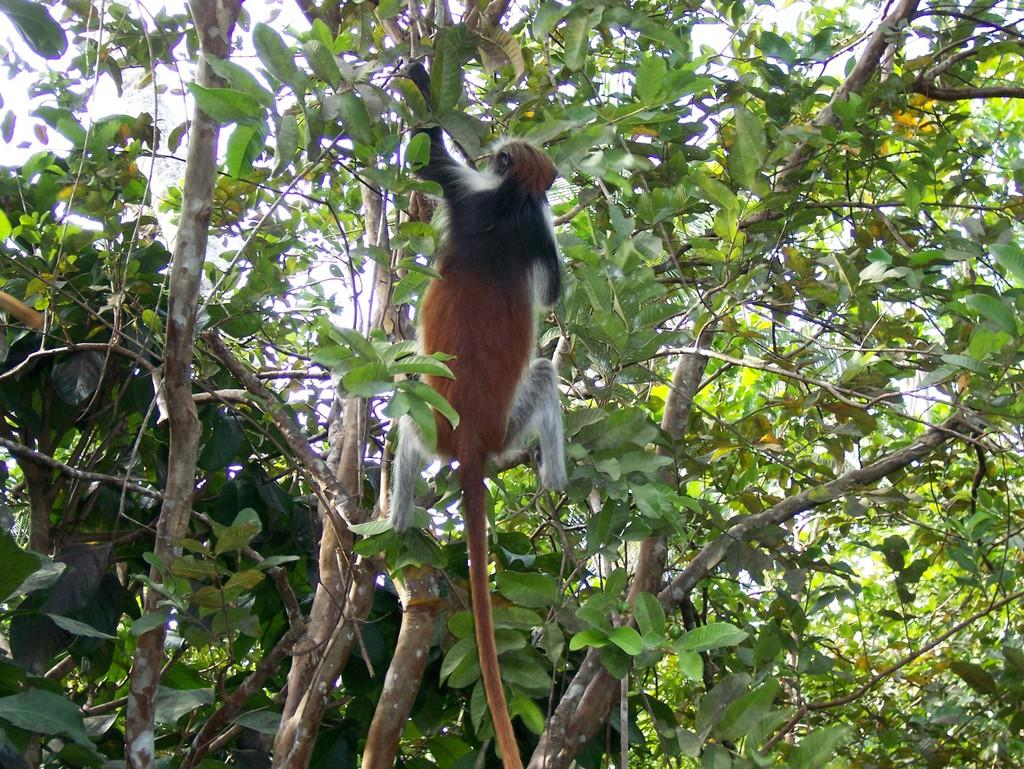What animal is present in the image? There is a monkey in the image. Where is the monkey located? The monkey is on a tree. What part of the natural environment is visible in the image? The sky is visible in the image. What type of rod can be seen in the monkey's hand in the image? There is no rod present in the image; the monkey is on a tree, but no rod is visible. 